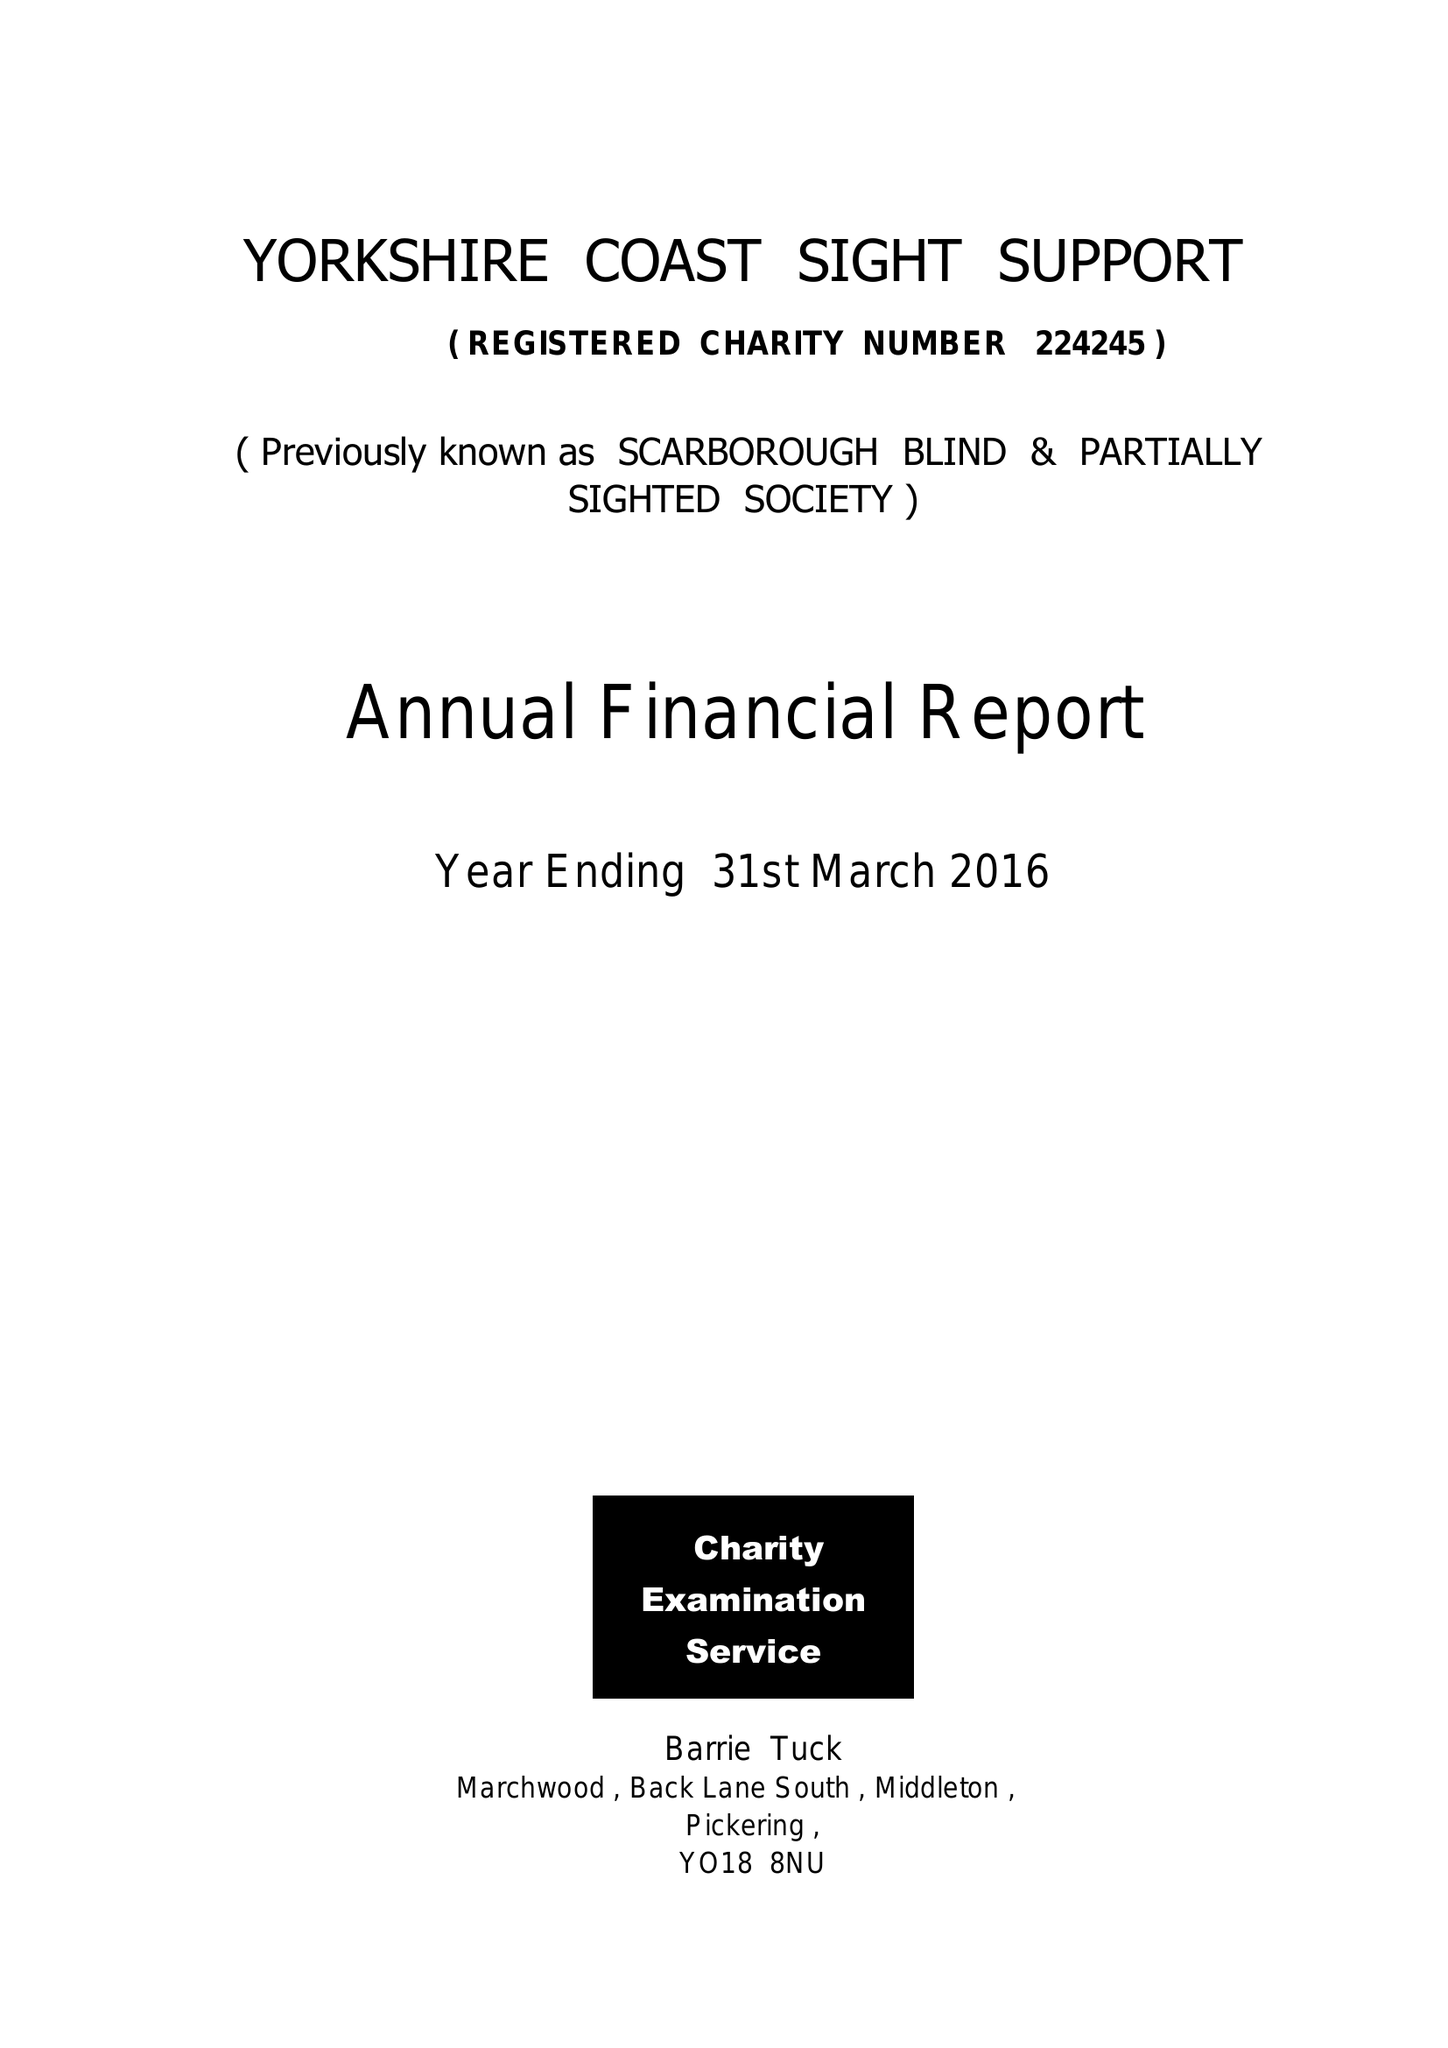What is the value for the address__postcode?
Answer the question using a single word or phrase. YO12 7JH 